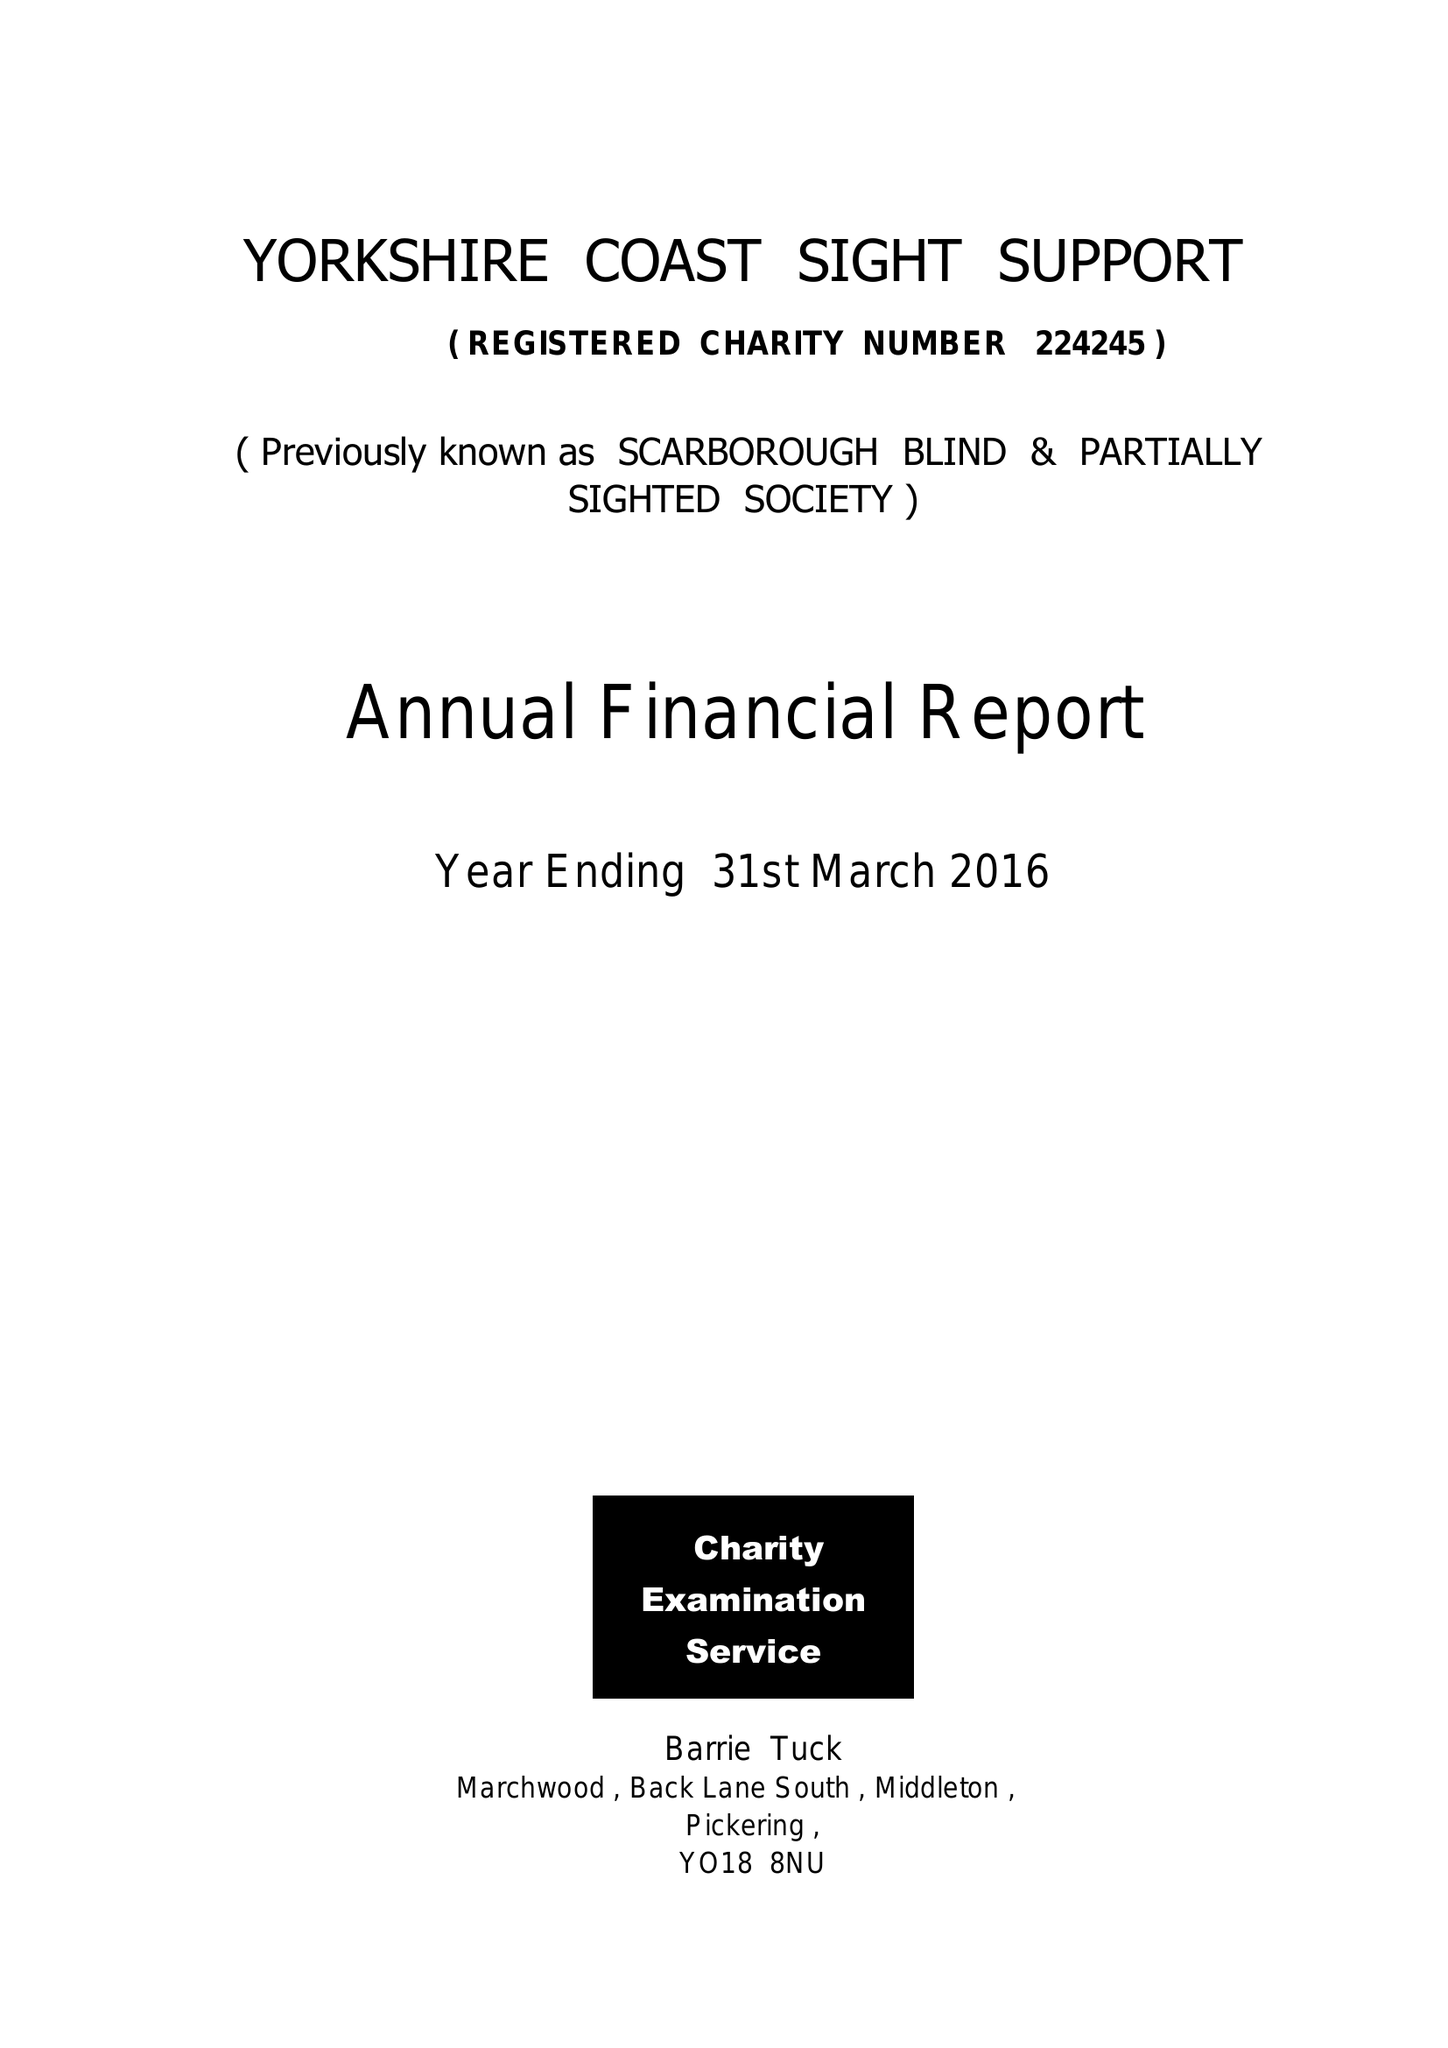What is the value for the address__postcode?
Answer the question using a single word or phrase. YO12 7JH 